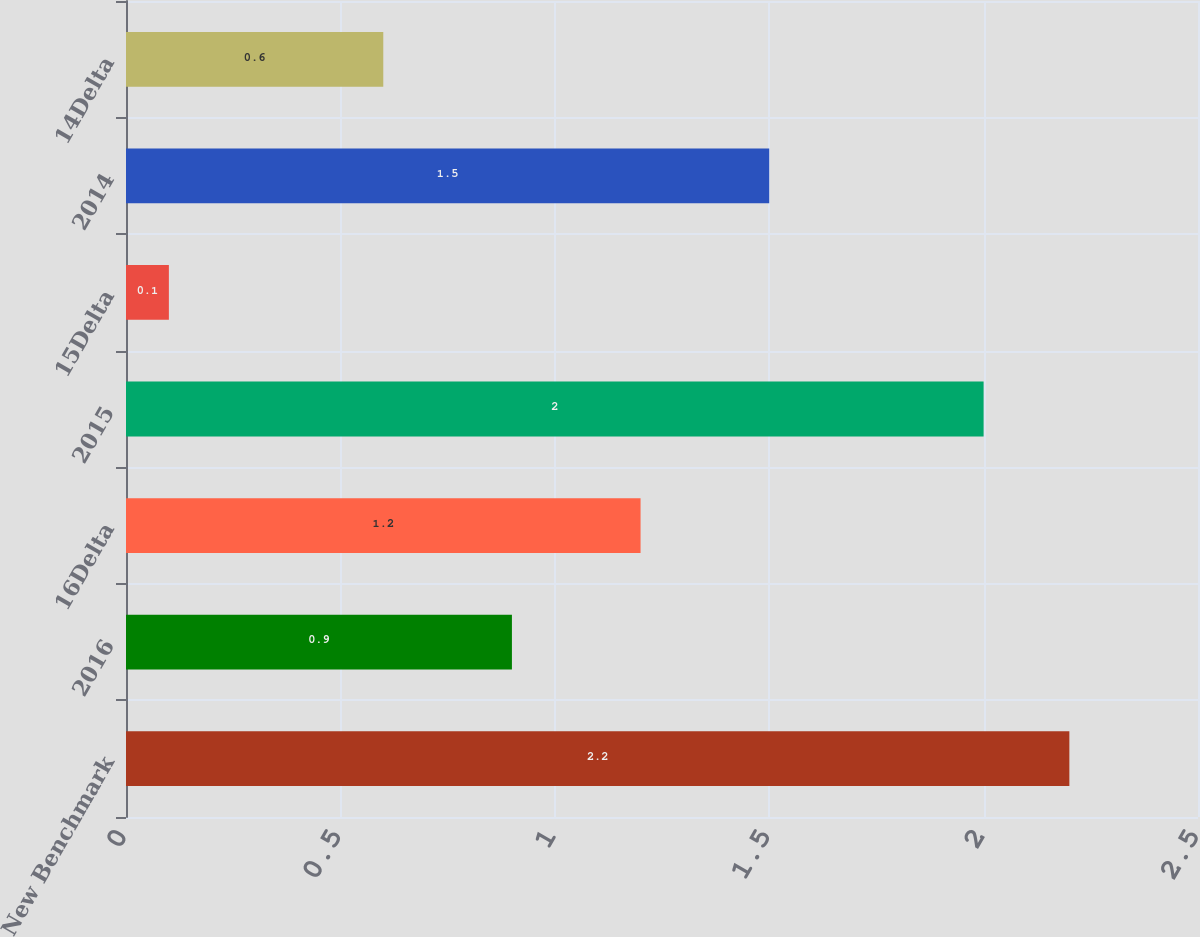Convert chart. <chart><loc_0><loc_0><loc_500><loc_500><bar_chart><fcel>New Benchmark<fcel>2016<fcel>16Delta<fcel>2015<fcel>15Delta<fcel>2014<fcel>14Delta<nl><fcel>2.2<fcel>0.9<fcel>1.2<fcel>2<fcel>0.1<fcel>1.5<fcel>0.6<nl></chart> 